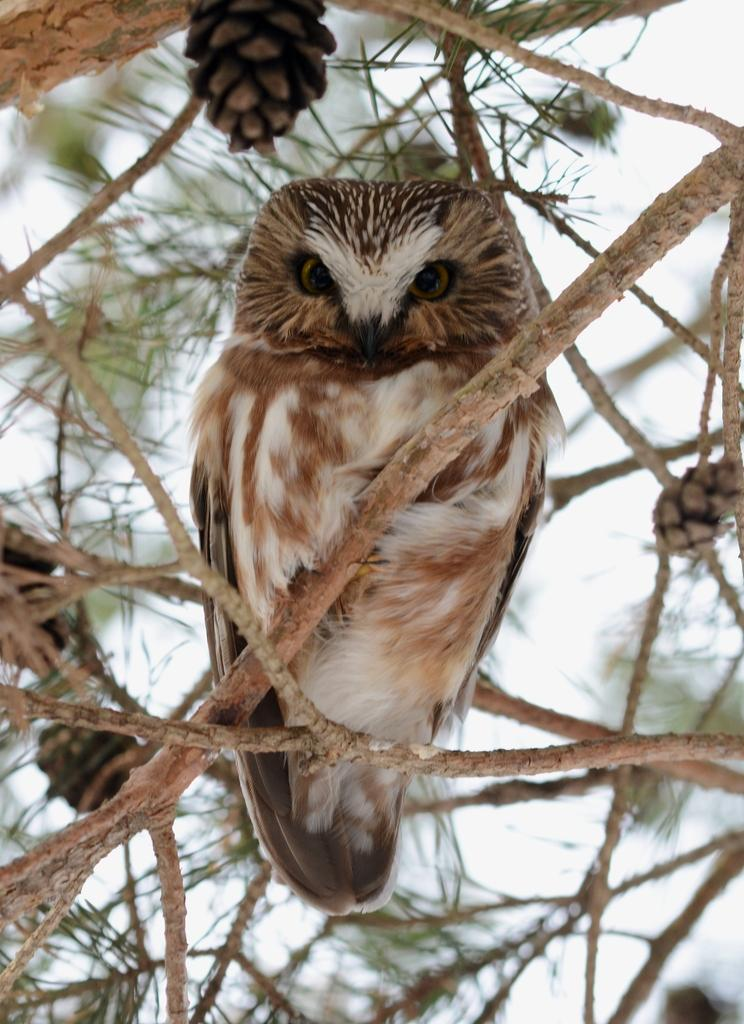What animal can be seen on the tree in the image? There is an eagle on a tree in the image. What else can be seen on the tree besides the eagle? There are fruits visible on the tree. What part of the tree is visible in the image? There are stems of the tree visible. What type of comb is being used by the eagle in the image? There is no comb present in the image; it features an eagle on a tree with fruits and stems visible. 